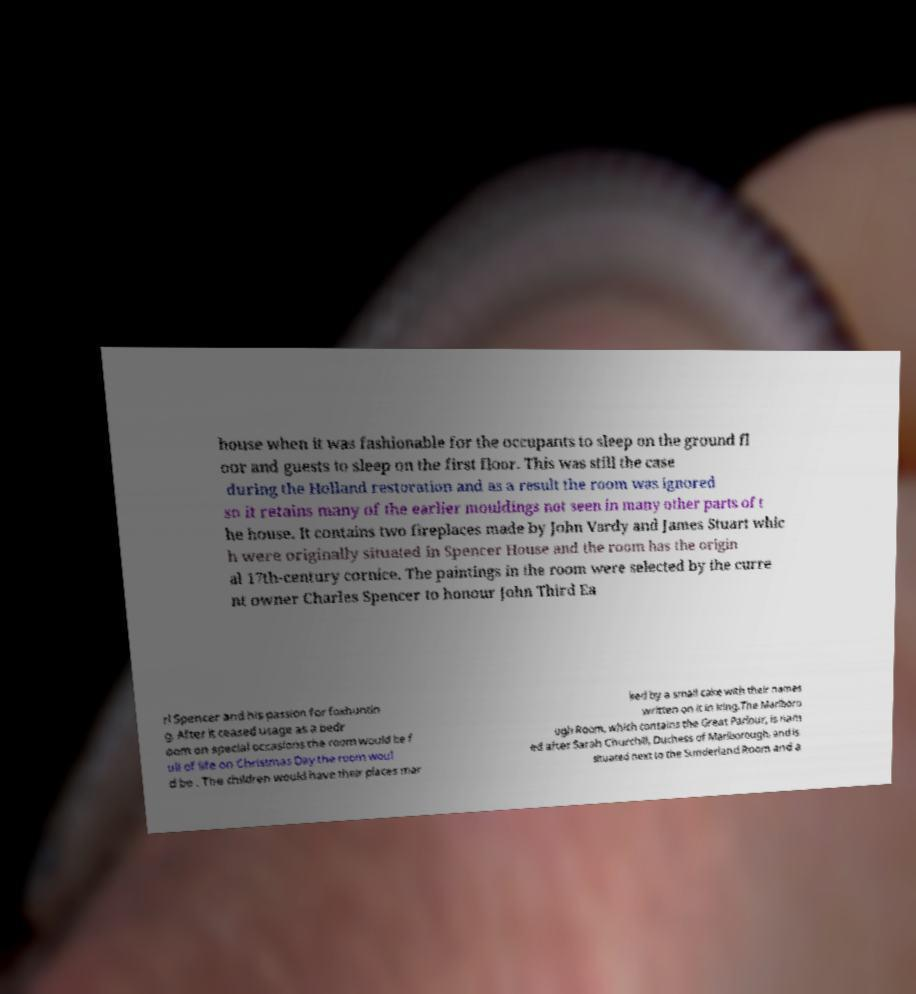Please read and relay the text visible in this image. What does it say? house when it was fashionable for the occupants to sleep on the ground fl oor and guests to sleep on the first floor. This was still the case during the Holland restoration and as a result the room was ignored so it retains many of the earlier mouldings not seen in many other parts of t he house. It contains two fireplaces made by John Vardy and James Stuart whic h were originally situated in Spencer House and the room has the origin al 17th-century cornice. The paintings in the room were selected by the curre nt owner Charles Spencer to honour John Third Ea rl Spencer and his passion for foxhuntin g. After it ceased usage as a bedr oom on special occasions the room would be f ull of life on Christmas Day the room woul d be . The children would have their places mar ked by a small cake with their names written on it in icing.The Marlboro ugh Room, which contains the Great Parlour, is nam ed after Sarah Churchill, Duchess of Marlborough, and is situated next to the Sunderland Room and a 